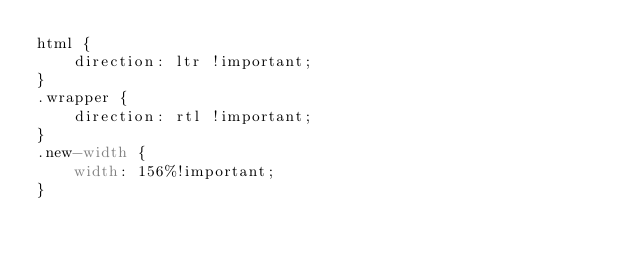Convert code to text. <code><loc_0><loc_0><loc_500><loc_500><_CSS_>html {
    direction: ltr !important;
}
.wrapper {
    direction: rtl !important;
}
.new-width {
    width: 156%!important;
}</code> 